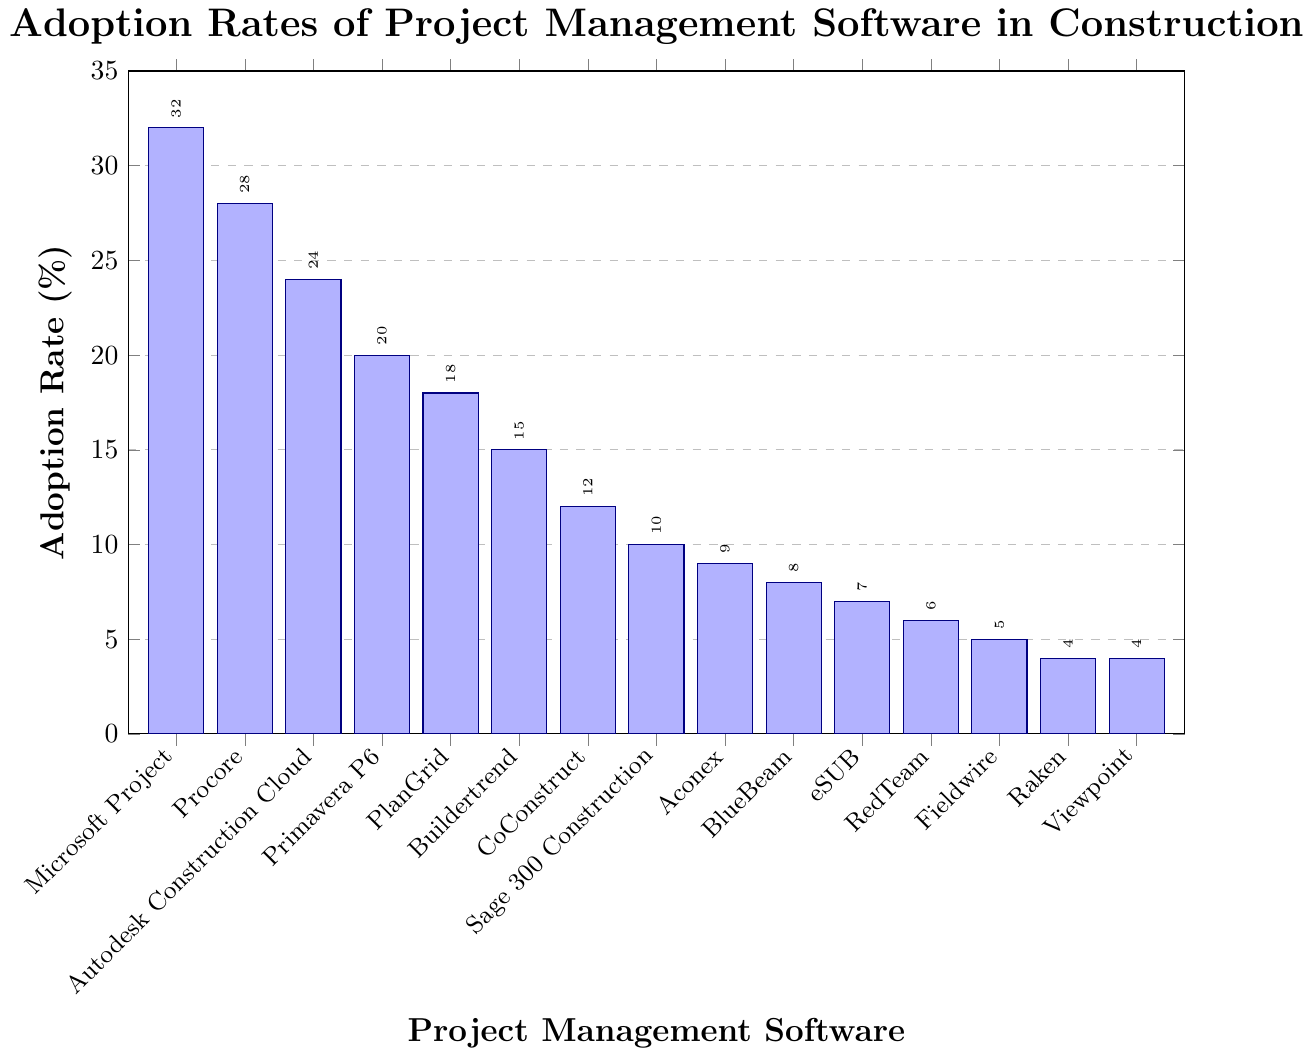How many project management software options have an adoption rate of 10% or lower? To find out how many software options have an adoption rate of 10% or lower, we need to count the bars whose height is at or below the 10% mark on the y-axis. The software with adoption rates 10% or lower are: Sage 300 Construction (10%), Aconex (9%), BlueBeam (8%), eSUB (7%), RedTeam (6%), Fieldwire (5%), Raken (4%), and Viewpoint (4%). This makes a total of 8 software options.
Answer: 8 Which software has the highest adoption rate, and what is that rate? To determine which software has the highest adoption rate, we look at the bar that reaches the highest point on the y-axis. The bar for Microsoft Project is the tallest, reaching an adoption rate of 32%.
Answer: Microsoft Project, 32% How much higher is the adoption rate of Procore compared to CoConstruct? To find out how much higher the adoption rate of Procore is compared to CoConstruct, we subtract the adoption rate of CoConstruct (12%) from the adoption rate of Procore (28%): 28% - 12% = 16%.
Answer: 16% Which software has the lowest adoption rate, and what is the rate? We look for the shortest bar on the chart to find the software with the lowest adoption rate. Both Raken and Viewpoint have the shortest bars with an adoption rate of 4%.
Answer: Raken and Viewpoint, 4% What is the average adoption rate of the top three most adopted software? To find the average adoption rate of the top three most adopted software, we first identify the adoption rates: Microsoft Project (32%), Procore (28%), and Autodesk Construction Cloud (24%). The sum of these rates is 32% + 28% + 24% = 84%. The average is then 84% / 3 = 28%.
Answer: 28% Is the adoption rate of PlanGrid greater than half the adoption rate of Microsoft Project? To determine if the adoption rate of PlanGrid (18%) is greater than half the adoption rate of Microsoft Project (32%), we calculate half of 32%, which is 32% / 2 = 16%. Since 18% is greater than 16%, the adoption rate of PlanGrid is indeed greater than half the adoption rate of Microsoft Project.
Answer: Yes What is the combined adoption rate of the software with adoption rates greater than 20%? The software with adoption rates greater than 20% are Microsoft Project (32%), Procore (28%), and Autodesk Construction Cloud (24%). Adding these rates together: 32% + 28% + 24% = 84%.
Answer: 84% What percentage of the total adoption rate do the less popular software (adoption rate less than or equal to 15%) contribute? First, identify the software with adoption rates less than or equal to 15%: Buildertrend (15%), CoConstruct (12%), Sage 300 Construction (10%), Aconex (9%), BlueBeam (8%), eSUB (7%), RedTeam (6%), Fieldwire (5%), Raken (4%), and Viewpoint (4%). Their total contribution is: 15% + 12% + 10% + 9% + 8% + 7% + 6% + 5% + 4% + 4% = 80%. The total adoption rate for all software would be the same as the sum of adoption rates: 32% + 28% + 24% + 20% + 18% + 15% + 12% + 10% + 9% + 8% + 7% + 6% + 5% + 4% + 4% = 222%. The percentage contribution of the less popular software is then (80/222) * 100% ≈ 36%.
Answer: 36% Arrange the adoption rates of different software in descending order. To arrange the adoption rates in descending order, list them from highest to lowest: Microsoft Project (32%), Procore (28%), Autodesk Construction Cloud (24%), Primavera P6 (20%), PlanGrid (18%), Buildertrend (15%), CoConstruct (12%), Sage 300 Construction (10%), Aconex (9%), BlueBeam (8%), eSUB (7%), RedTeam (6%), Fieldwire (5%), Raken (4%), Viewpoint (4%).
Answer: Microsoft Project, Procore, Autodesk Construction Cloud, Primavera P6, PlanGrid, Buildertrend, CoConstruct, Sage 300 Construction, Aconex, BlueBeam, eSUB, RedTeam, Fieldwire, Raken, Viewpoint 